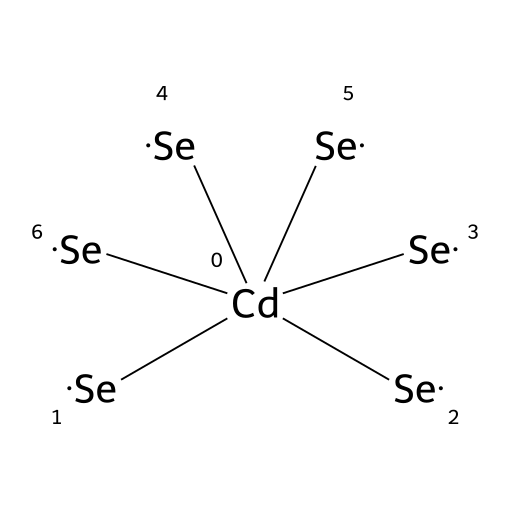What is the central atom in this quantum dot structure? The structure shows a cadmium atom, denoted by [Cd], which is at the center surrounded by selenium atoms.
Answer: cadmium How many selenium atoms are present in this chemical structure? The SMILES notation lists six selenium atoms, indicated by six occurrences of [Se] surrounding the central cadmium atom.
Answer: six What type of chemical bond connects cadmium and selenium in this structure? The atoms are likely connected by ionic or covalent bonds, typical for a metal and nonmetal pairing, but specifically in quantum dots, it is known to be predominantly covalent due to the sharing of electrons.
Answer: covalent What is this quantum dot's primary application in technology? Cadmium selenide quantum dots are primarily used in display technologies for enhancing color and efficiency, leveraging their unique optical properties.
Answer: display technologies Would this quantum dot be classified as a semiconductor? Given that cadmium selenide has properties that allow it to conduct electricity under certain conditions while behaving like an insulator under others, it fits the definition of a semiconductor.
Answer: semiconductor How does the size of cadmium selenide quantum dots affect their optical properties? The optical properties, particularly emission wavelengths, vary based on the size of the quantum dots; smaller dots emit light at shorter wavelengths (bluer), while larger dots emit at longer wavelengths (redder), a phenomenon known as quantum confinement.
Answer: quantum confinement 